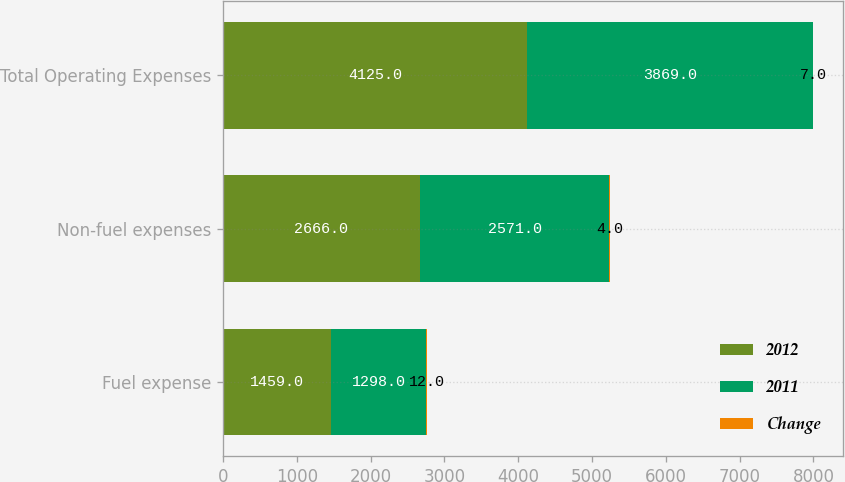Convert chart to OTSL. <chart><loc_0><loc_0><loc_500><loc_500><stacked_bar_chart><ecel><fcel>Fuel expense<fcel>Non-fuel expenses<fcel>Total Operating Expenses<nl><fcel>2012<fcel>1459<fcel>2666<fcel>4125<nl><fcel>2011<fcel>1298<fcel>2571<fcel>3869<nl><fcel>Change<fcel>12<fcel>4<fcel>7<nl></chart> 